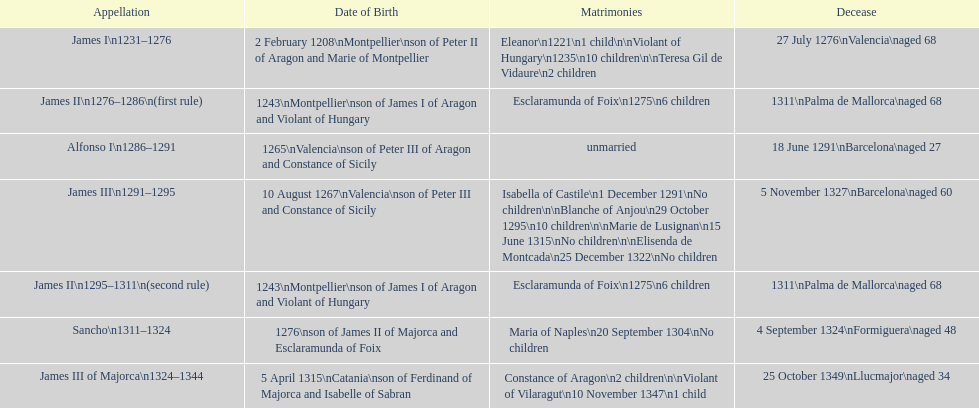How many total marriages did james i have? 3. 